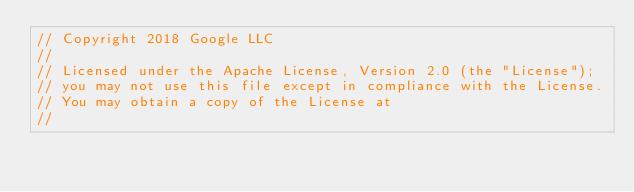<code> <loc_0><loc_0><loc_500><loc_500><_ObjectiveC_>// Copyright 2018 Google LLC
//
// Licensed under the Apache License, Version 2.0 (the "License");
// you may not use this file except in compliance with the License.
// You may obtain a copy of the License at
//</code> 